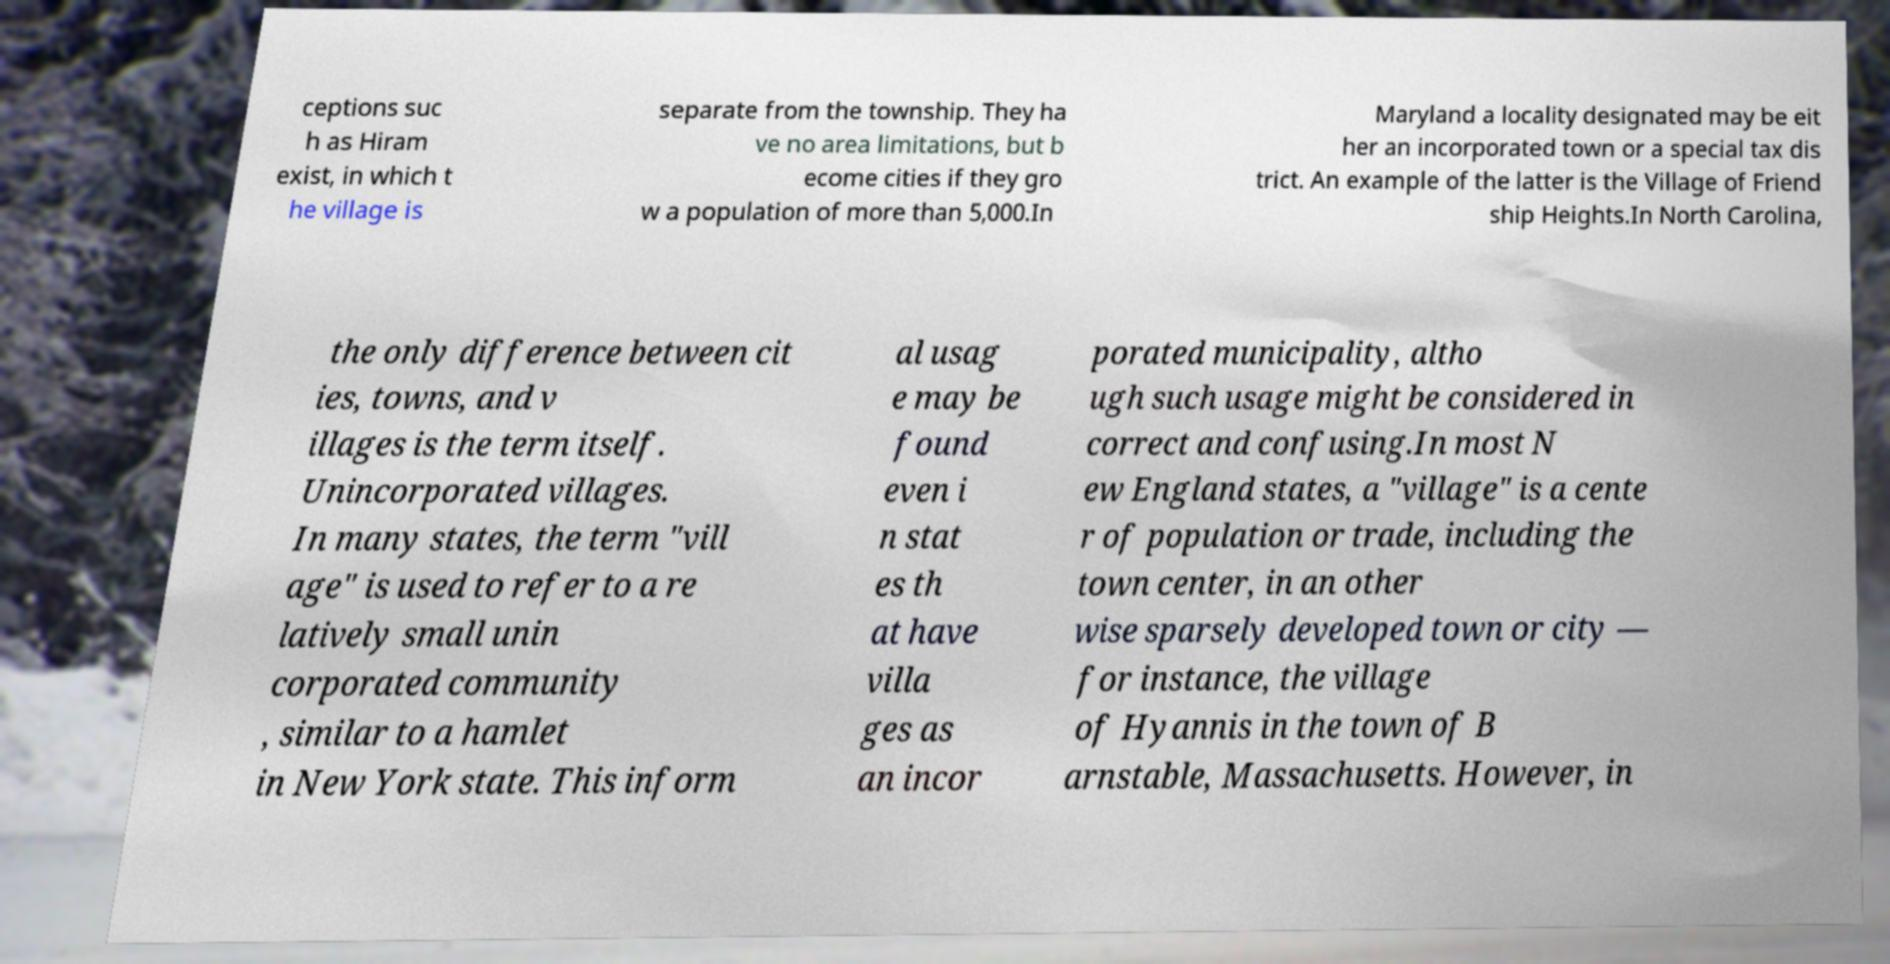Can you accurately transcribe the text from the provided image for me? ceptions suc h as Hiram exist, in which t he village is separate from the township. They ha ve no area limitations, but b ecome cities if they gro w a population of more than 5,000.In Maryland a locality designated may be eit her an incorporated town or a special tax dis trict. An example of the latter is the Village of Friend ship Heights.In North Carolina, the only difference between cit ies, towns, and v illages is the term itself. Unincorporated villages. In many states, the term "vill age" is used to refer to a re latively small unin corporated community , similar to a hamlet in New York state. This inform al usag e may be found even i n stat es th at have villa ges as an incor porated municipality, altho ugh such usage might be considered in correct and confusing.In most N ew England states, a "village" is a cente r of population or trade, including the town center, in an other wise sparsely developed town or city — for instance, the village of Hyannis in the town of B arnstable, Massachusetts. However, in 